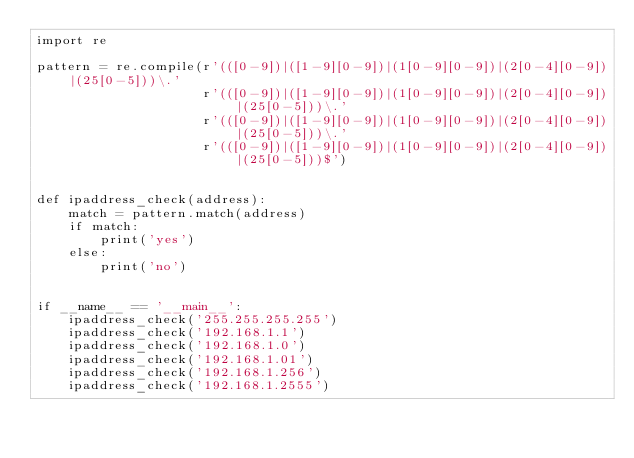Convert code to text. <code><loc_0><loc_0><loc_500><loc_500><_Python_>import re

pattern = re.compile(r'(([0-9])|([1-9][0-9])|(1[0-9][0-9])|(2[0-4][0-9])|(25[0-5]))\.'
                     r'(([0-9])|([1-9][0-9])|(1[0-9][0-9])|(2[0-4][0-9])|(25[0-5]))\.'
                     r'(([0-9])|([1-9][0-9])|(1[0-9][0-9])|(2[0-4][0-9])|(25[0-5]))\.'
                     r'(([0-9])|([1-9][0-9])|(1[0-9][0-9])|(2[0-4][0-9])|(25[0-5]))$')


def ipaddress_check(address):
    match = pattern.match(address)
    if match:
        print('yes')
    else:
        print('no')


if __name__ == '__main__':
    ipaddress_check('255.255.255.255')
    ipaddress_check('192.168.1.1')
    ipaddress_check('192.168.1.0')
    ipaddress_check('192.168.1.01')
    ipaddress_check('192.168.1.256')
    ipaddress_check('192.168.1.2555')
</code> 